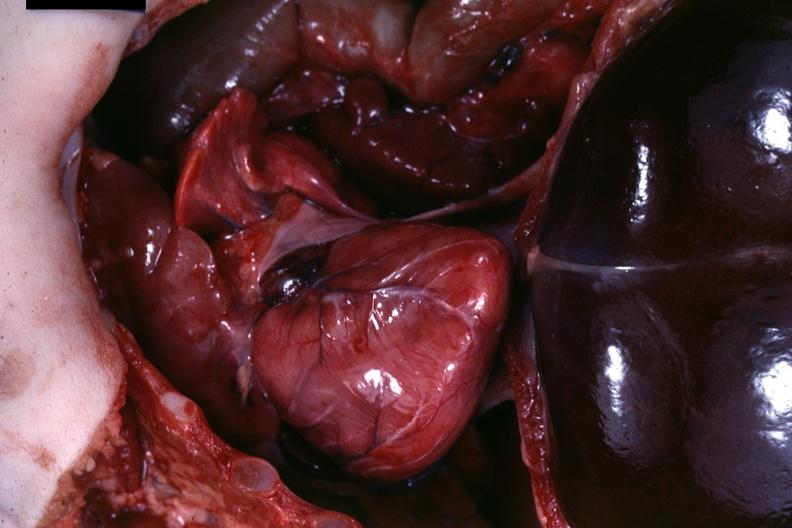what is present?
Answer the question using a single word or phrase. Muscle 